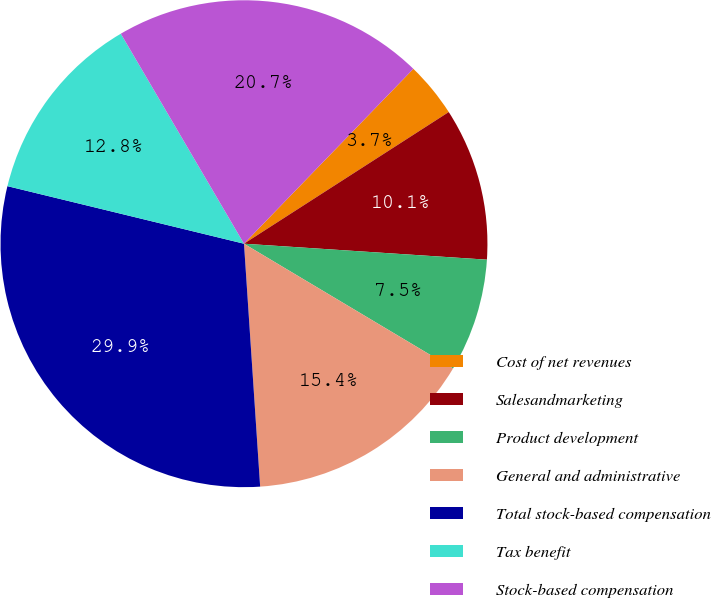Convert chart to OTSL. <chart><loc_0><loc_0><loc_500><loc_500><pie_chart><fcel>Cost of net revenues<fcel>Salesandmarketing<fcel>Product development<fcel>General and administrative<fcel>Total stock-based compensation<fcel>Tax benefit<fcel>Stock-based compensation<nl><fcel>3.66%<fcel>10.14%<fcel>7.52%<fcel>15.38%<fcel>29.86%<fcel>12.76%<fcel>20.69%<nl></chart> 